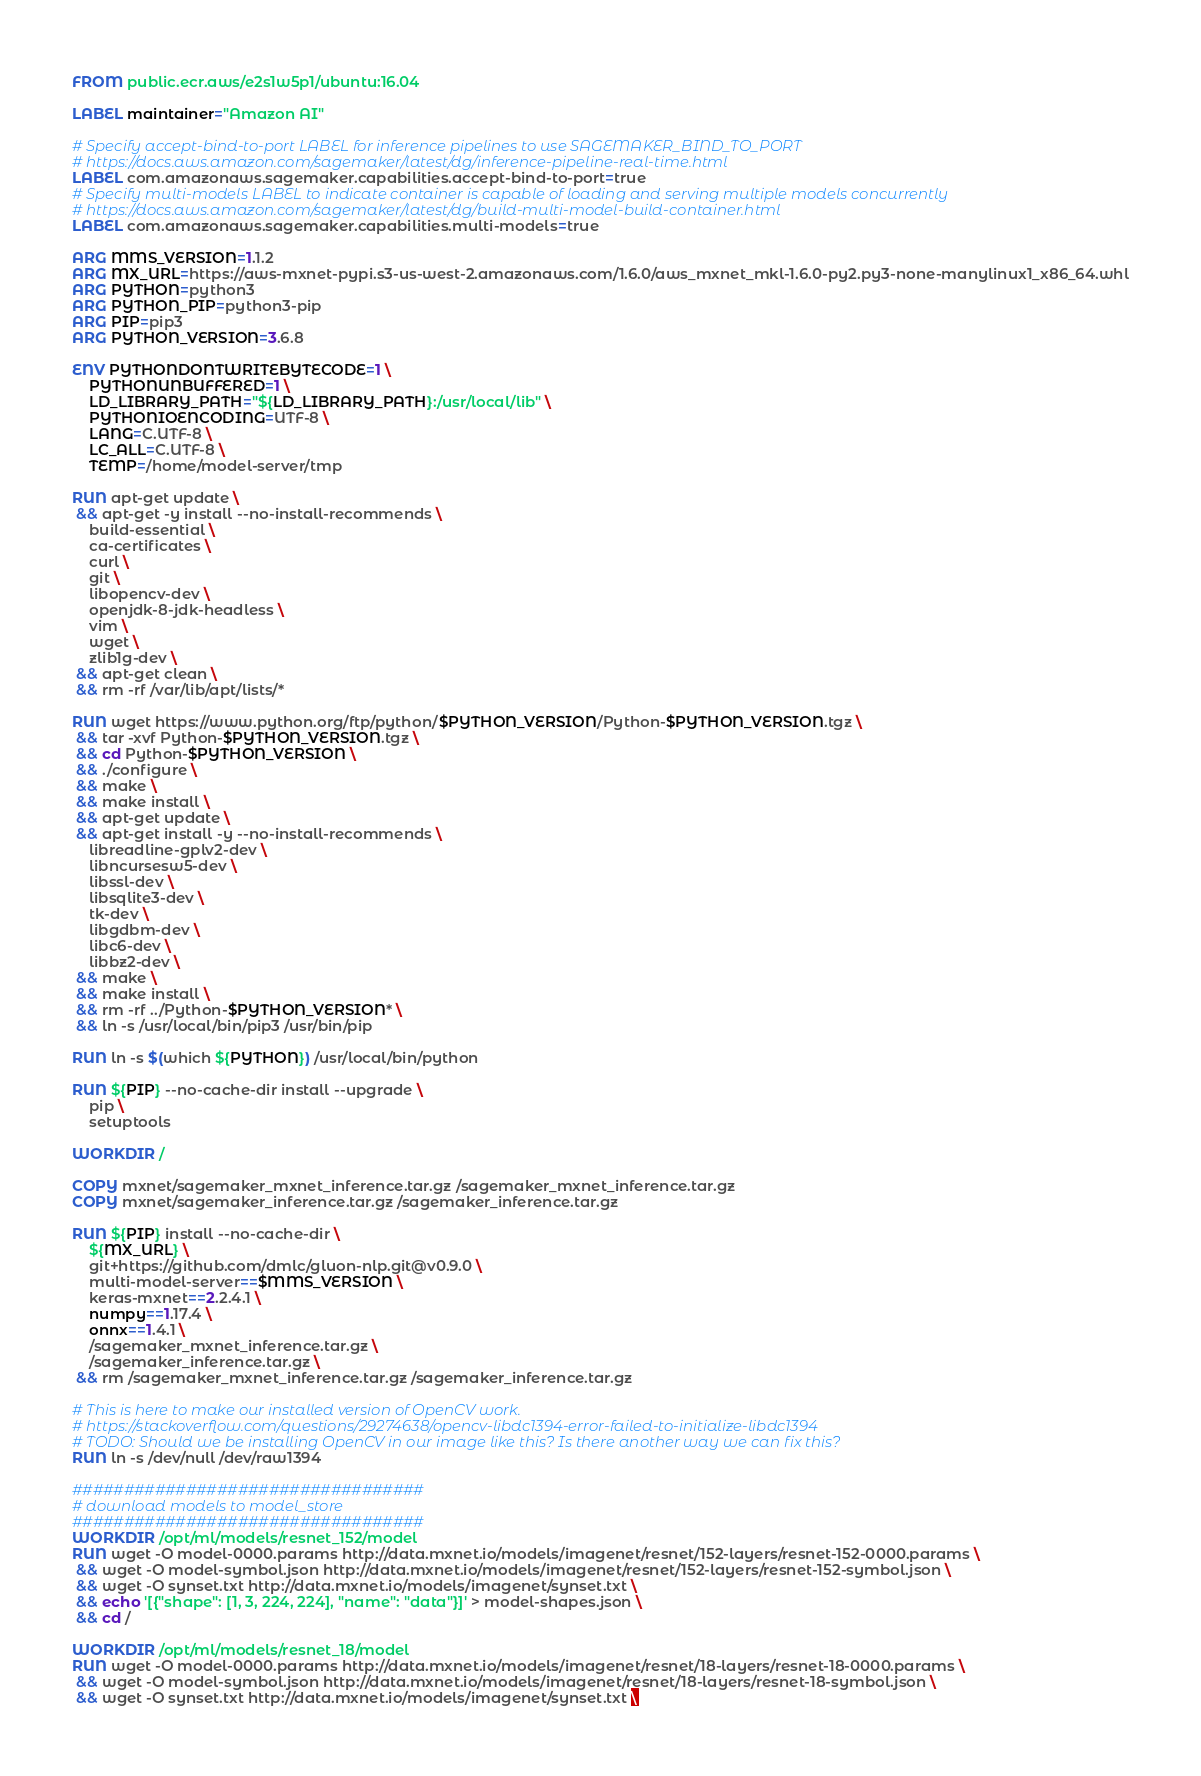<code> <loc_0><loc_0><loc_500><loc_500><_Dockerfile_>FROM public.ecr.aws/e2s1w5p1/ubuntu:16.04

LABEL maintainer="Amazon AI"

# Specify accept-bind-to-port LABEL for inference pipelines to use SAGEMAKER_BIND_TO_PORT
# https://docs.aws.amazon.com/sagemaker/latest/dg/inference-pipeline-real-time.html
LABEL com.amazonaws.sagemaker.capabilities.accept-bind-to-port=true
# Specify multi-models LABEL to indicate container is capable of loading and serving multiple models concurrently
# https://docs.aws.amazon.com/sagemaker/latest/dg/build-multi-model-build-container.html
LABEL com.amazonaws.sagemaker.capabilities.multi-models=true

ARG MMS_VERSION=1.1.2
ARG MX_URL=https://aws-mxnet-pypi.s3-us-west-2.amazonaws.com/1.6.0/aws_mxnet_mkl-1.6.0-py2.py3-none-manylinux1_x86_64.whl
ARG PYTHON=python3
ARG PYTHON_PIP=python3-pip
ARG PIP=pip3
ARG PYTHON_VERSION=3.6.8

ENV PYTHONDONTWRITEBYTECODE=1 \
    PYTHONUNBUFFERED=1 \
    LD_LIBRARY_PATH="${LD_LIBRARY_PATH}:/usr/local/lib" \
    PYTHONIOENCODING=UTF-8 \
    LANG=C.UTF-8 \
    LC_ALL=C.UTF-8 \
    TEMP=/home/model-server/tmp

RUN apt-get update \
 && apt-get -y install --no-install-recommends \
    build-essential \
    ca-certificates \
    curl \
    git \
    libopencv-dev \
    openjdk-8-jdk-headless \
    vim \
    wget \
    zlib1g-dev \
 && apt-get clean \
 && rm -rf /var/lib/apt/lists/*

RUN wget https://www.python.org/ftp/python/$PYTHON_VERSION/Python-$PYTHON_VERSION.tgz \
 && tar -xvf Python-$PYTHON_VERSION.tgz \
 && cd Python-$PYTHON_VERSION \
 && ./configure \
 && make \
 && make install \
 && apt-get update \
 && apt-get install -y --no-install-recommends \
    libreadline-gplv2-dev \
    libncursesw5-dev \
    libssl-dev \
    libsqlite3-dev \
    tk-dev \
    libgdbm-dev \
    libc6-dev \
    libbz2-dev \
 && make \
 && make install \
 && rm -rf ../Python-$PYTHON_VERSION* \
 && ln -s /usr/local/bin/pip3 /usr/bin/pip

RUN ln -s $(which ${PYTHON}) /usr/local/bin/python

RUN ${PIP} --no-cache-dir install --upgrade \
    pip \
    setuptools

WORKDIR /

COPY mxnet/sagemaker_mxnet_inference.tar.gz /sagemaker_mxnet_inference.tar.gz
COPY mxnet/sagemaker_inference.tar.gz /sagemaker_inference.tar.gz

RUN ${PIP} install --no-cache-dir \
    ${MX_URL} \
    git+https://github.com/dmlc/gluon-nlp.git@v0.9.0 \
    multi-model-server==$MMS_VERSION \
    keras-mxnet==2.2.4.1 \
    numpy==1.17.4 \
    onnx==1.4.1 \
    /sagemaker_mxnet_inference.tar.gz \
    /sagemaker_inference.tar.gz \
 && rm /sagemaker_mxnet_inference.tar.gz /sagemaker_inference.tar.gz

# This is here to make our installed version of OpenCV work.
# https://stackoverflow.com/questions/29274638/opencv-libdc1394-error-failed-to-initialize-libdc1394
# TODO: Should we be installing OpenCV in our image like this? Is there another way we can fix this?
RUN ln -s /dev/null /dev/raw1394

##################################
# download models to model_store
##################################
WORKDIR /opt/ml/models/resnet_152/model
RUN wget -O model-0000.params http://data.mxnet.io/models/imagenet/resnet/152-layers/resnet-152-0000.params \
 && wget -O model-symbol.json http://data.mxnet.io/models/imagenet/resnet/152-layers/resnet-152-symbol.json \
 && wget -O synset.txt http://data.mxnet.io/models/imagenet/synset.txt \
 && echo '[{"shape": [1, 3, 224, 224], "name": "data"}]' > model-shapes.json \
 && cd /

WORKDIR /opt/ml/models/resnet_18/model
RUN wget -O model-0000.params http://data.mxnet.io/models/imagenet/resnet/18-layers/resnet-18-0000.params \
 && wget -O model-symbol.json http://data.mxnet.io/models/imagenet/resnet/18-layers/resnet-18-symbol.json \
 && wget -O synset.txt http://data.mxnet.io/models/imagenet/synset.txt \</code> 